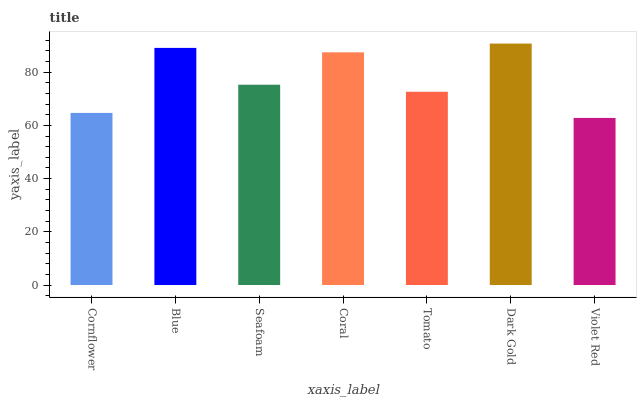Is Violet Red the minimum?
Answer yes or no. Yes. Is Dark Gold the maximum?
Answer yes or no. Yes. Is Blue the minimum?
Answer yes or no. No. Is Blue the maximum?
Answer yes or no. No. Is Blue greater than Cornflower?
Answer yes or no. Yes. Is Cornflower less than Blue?
Answer yes or no. Yes. Is Cornflower greater than Blue?
Answer yes or no. No. Is Blue less than Cornflower?
Answer yes or no. No. Is Seafoam the high median?
Answer yes or no. Yes. Is Seafoam the low median?
Answer yes or no. Yes. Is Blue the high median?
Answer yes or no. No. Is Tomato the low median?
Answer yes or no. No. 